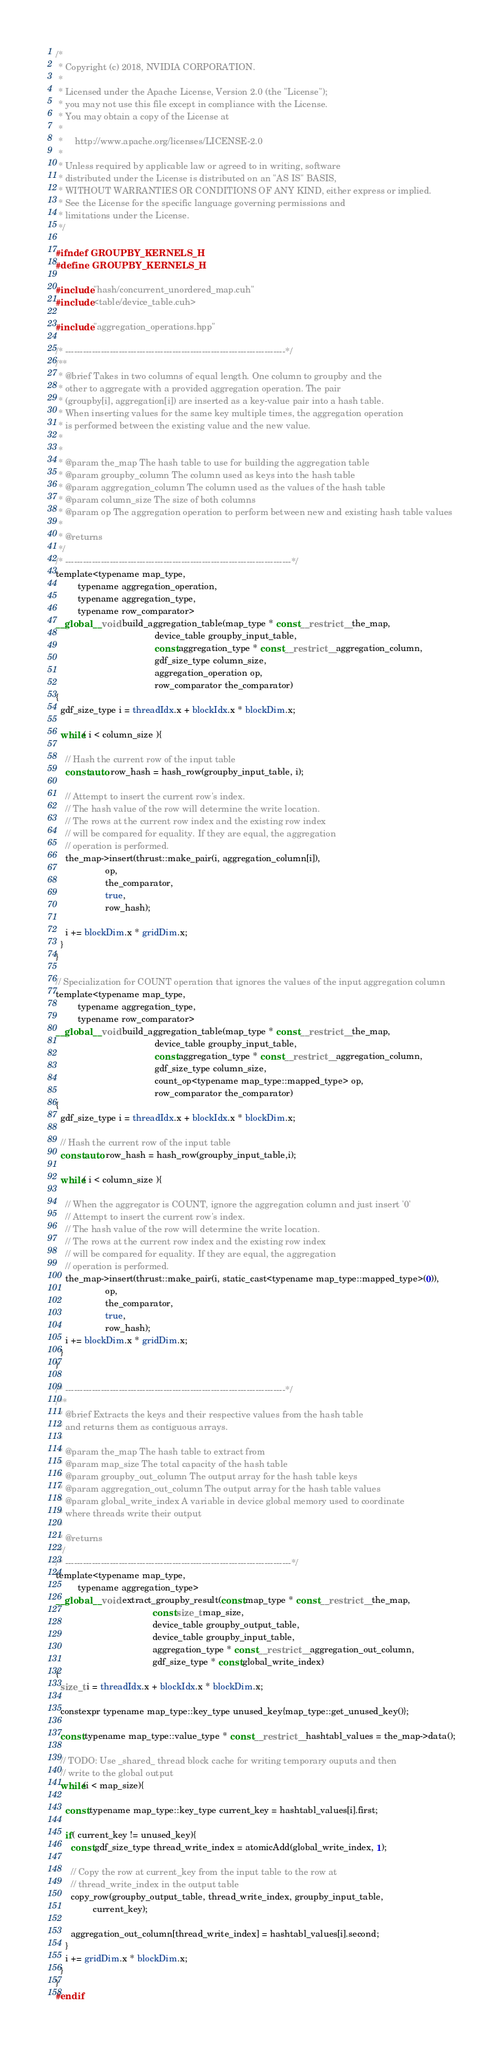Convert code to text. <code><loc_0><loc_0><loc_500><loc_500><_Cuda_>/*
 * Copyright (c) 2018, NVIDIA CORPORATION.
 *
 * Licensed under the Apache License, Version 2.0 (the "License");
 * you may not use this file except in compliance with the License.
 * You may obtain a copy of the License at
 *
 *     http://www.apache.org/licenses/LICENSE-2.0
 *
 * Unless required by applicable law or agreed to in writing, software
 * distributed under the License is distributed on an "AS IS" BASIS,
 * WITHOUT WARRANTIES OR CONDITIONS OF ANY KIND, either express or implied.
 * See the License for the specific language governing permissions and
 * limitations under the License.
 */

#ifndef GROUPBY_KERNELS_H
#define GROUPBY_KERNELS_H

#include "hash/concurrent_unordered_map.cuh"
#include <table/device_table.cuh>

#include "aggregation_operations.hpp"

/* --------------------------------------------------------------------------*/
/** 
 * @brief Takes in two columns of equal length. One column to groupby and the
 * other to aggregate with a provided aggregation operation. The pair
 * (groupby[i], aggregation[i]) are inserted as a key-value pair into a hash table.
 * When inserting values for the same key multiple times, the aggregation operation 
 * is performed between the existing value and the new value.
 *            
 * 
 * @param the_map The hash table to use for building the aggregation table
 * @param groupby_column The column used as keys into the hash table
 * @param aggregation_column The column used as the values of the hash table
 * @param column_size The size of both columns
 * @param op The aggregation operation to perform between new and existing hash table values
 * 
 * @returns   
 */
/* ----------------------------------------------------------------------------*/
template<typename map_type, 
         typename aggregation_operation,
         typename aggregation_type,
         typename row_comparator>
__global__ void build_aggregation_table(map_type * const __restrict__ the_map,
                                        device_table groupby_input_table,
                                        const aggregation_type * const __restrict__ aggregation_column,
                                        gdf_size_type column_size,
                                        aggregation_operation op,
                                        row_comparator the_comparator)
{
  gdf_size_type i = threadIdx.x + blockIdx.x * blockDim.x;

  while( i < column_size ){

    // Hash the current row of the input table
    const auto row_hash = hash_row(groupby_input_table, i);

    // Attempt to insert the current row's index.  
    // The hash value of the row will determine the write location.
    // The rows at the current row index and the existing row index 
    // will be compared for equality. If they are equal, the aggregation
    // operation is performed.
    the_map->insert(thrust::make_pair(i, aggregation_column[i]), 
                    op,
                    the_comparator,
                    true,
                    row_hash);

    i += blockDim.x * gridDim.x;
  }
}

// Specialization for COUNT operation that ignores the values of the input aggregation column
template<typename map_type,
         typename aggregation_type,
         typename row_comparator>
__global__ void build_aggregation_table(map_type * const __restrict__ the_map,
                                        device_table groupby_input_table,
                                        const aggregation_type * const __restrict__ aggregation_column,
                                        gdf_size_type column_size,
                                        count_op<typename map_type::mapped_type> op,
                                        row_comparator the_comparator)
{
  gdf_size_type i = threadIdx.x + blockIdx.x * blockDim.x;

  // Hash the current row of the input table
  const auto row_hash = hash_row(groupby_input_table,i);

  while( i < column_size ){

    // When the aggregator is COUNT, ignore the aggregation column and just insert '0'
    // Attempt to insert the current row's index.  
    // The hash value of the row will determine the write location.
    // The rows at the current row index and the existing row index 
    // will be compared for equality. If they are equal, the aggregation
    // operation is performed.
    the_map->insert(thrust::make_pair(i, static_cast<typename map_type::mapped_type>(0)), 
                    op,
                    the_comparator,
                    true,
                    row_hash);
    i += blockDim.x * gridDim.x;
  }
}

/* --------------------------------------------------------------------------*/
/** 
 * @brief Extracts the keys and their respective values from the hash table
 * and returns them as contiguous arrays.
 * 
 * @param the_map The hash table to extract from 
 * @param map_size The total capacity of the hash table
 * @param groupby_out_column The output array for the hash table keys
 * @param aggregation_out_column The output array for the hash table values
 * @param global_write_index A variable in device global memory used to coordinate
 * where threads write their output
 * 
 * @returns   
 */
/* ----------------------------------------------------------------------------*/
template<typename map_type,
         typename aggregation_type>
__global__ void extract_groupby_result(const map_type * const __restrict__ the_map,
                                       const size_t map_size,
                                       device_table groupby_output_table,
                                       device_table groupby_input_table,
                                       aggregation_type * const __restrict__ aggregation_out_column,
                                       gdf_size_type * const global_write_index)
{
  size_t i = threadIdx.x + blockIdx.x * blockDim.x;

  constexpr typename map_type::key_type unused_key{map_type::get_unused_key()};

  const typename map_type::value_type * const __restrict__ hashtabl_values = the_map->data();

  // TODO: Use _shared_ thread block cache for writing temporary ouputs and then
  // write to the global output
  while(i < map_size){

    const typename map_type::key_type current_key = hashtabl_values[i].first;

    if( current_key != unused_key){
      const gdf_size_type thread_write_index = atomicAdd(global_write_index, 1);

      // Copy the row at current_key from the input table to the row at
      // thread_write_index in the output table
      copy_row(groupby_output_table, thread_write_index, groupby_input_table,
               current_key);

      aggregation_out_column[thread_write_index] = hashtabl_values[i].second;
    }
    i += gridDim.x * blockDim.x;
  }
}
#endif
</code> 